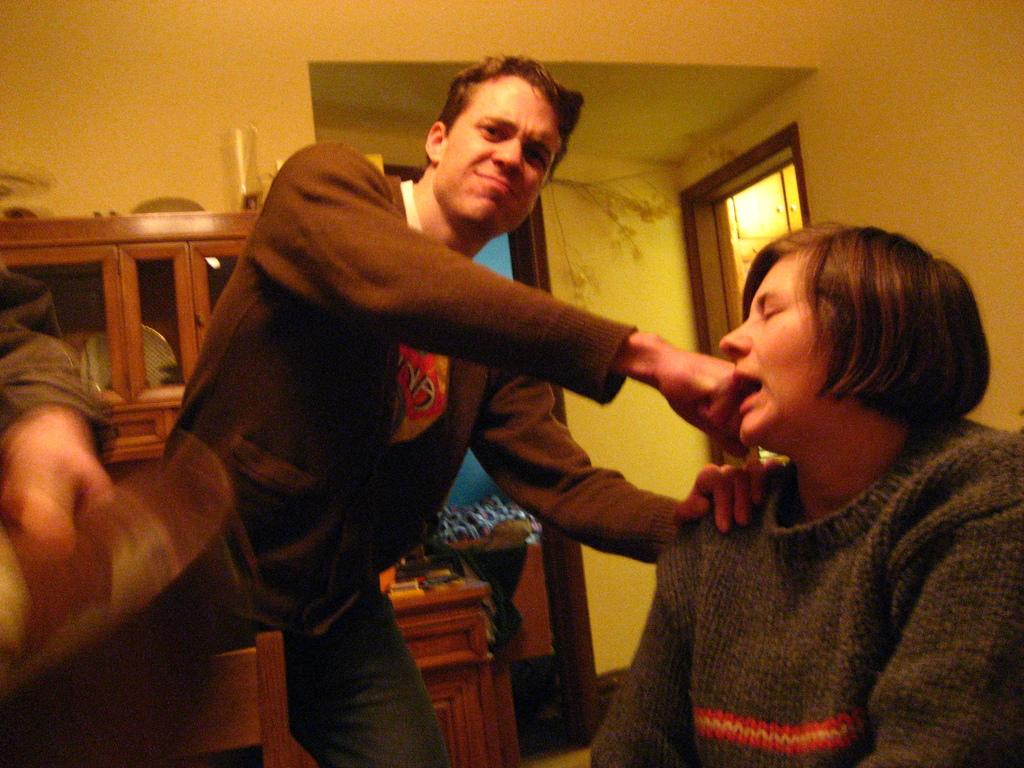What are the people in the image doing? There are persons sitting and standing in the image. What can be seen in the background of the image? There is a cupboard and doors in the background of the image. Can you describe an object on top of the cupboard? There is a glass on top of the cupboard. What advice is the person giving with their toes in the image? There is no mention of toes or advice being given in the image. The image only shows persons sitting and standing, a cupboard, doors, and a glass on top of the cupboard. 